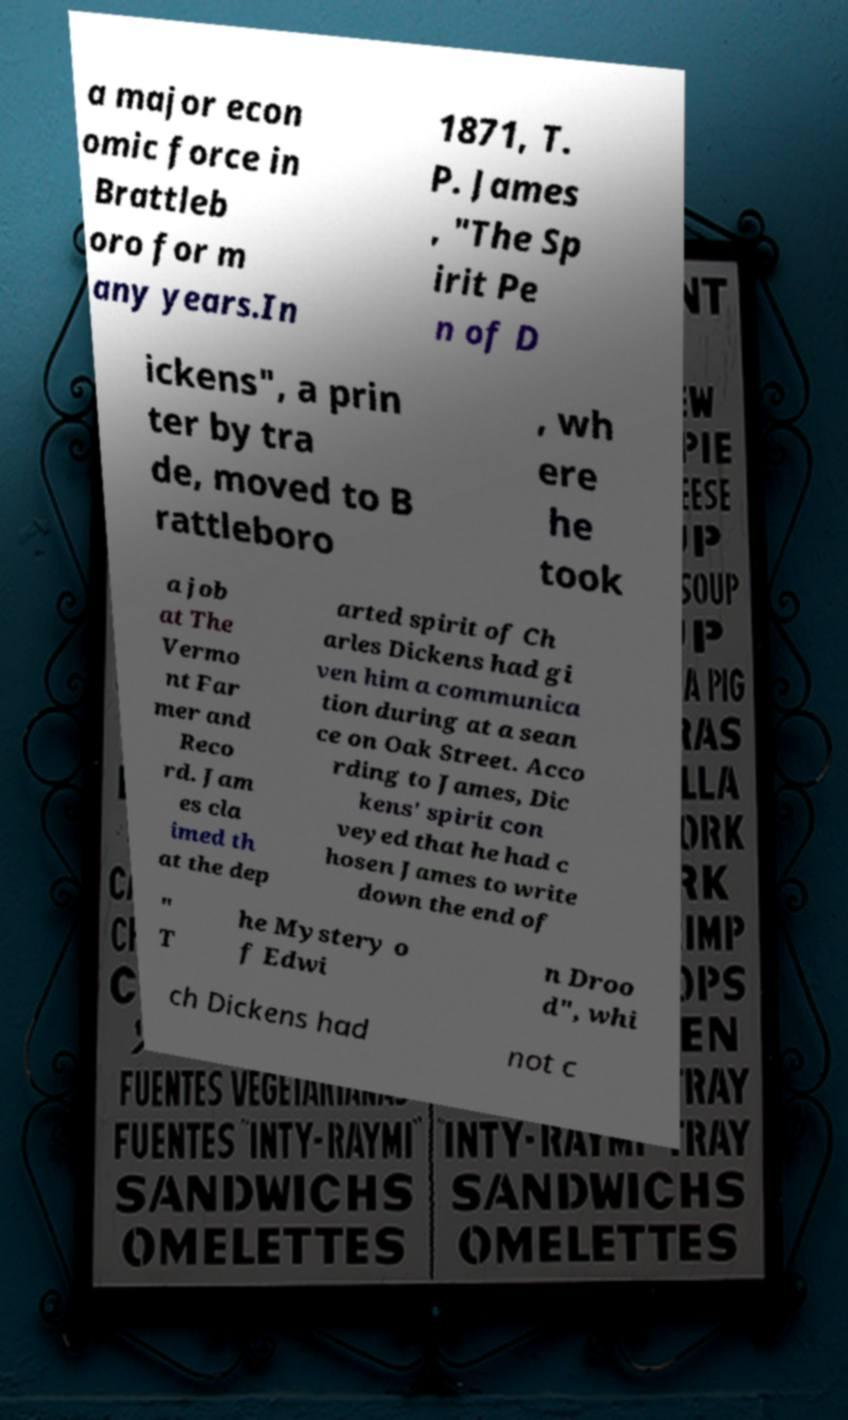Please identify and transcribe the text found in this image. a major econ omic force in Brattleb oro for m any years.In 1871, T. P. James , "The Sp irit Pe n of D ickens", a prin ter by tra de, moved to B rattleboro , wh ere he took a job at The Vermo nt Far mer and Reco rd. Jam es cla imed th at the dep arted spirit of Ch arles Dickens had gi ven him a communica tion during at a sean ce on Oak Street. Acco rding to James, Dic kens' spirit con veyed that he had c hosen James to write down the end of " T he Mystery o f Edwi n Droo d", whi ch Dickens had not c 